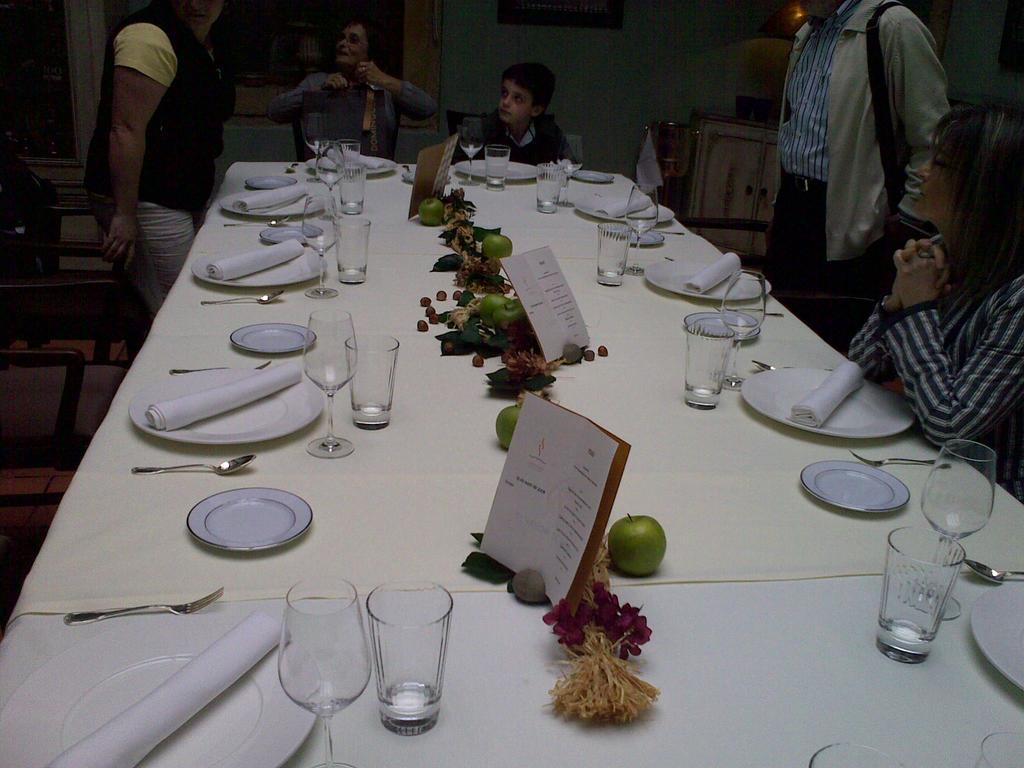What piece of furniture is present in the image? There is a table in the image. What utensils can be seen on the table? There are forks and spoons on the table. What else is on the table besides utensils? There are plates, glasses, and fruits on the table. Who is present in the image? There are people sitting on chairs in the image. What type of meat is being served in the downtown area in the image? There is no mention of meat or a downtown area in the image; it features a table with utensils, plates, glasses, fruits, and people sitting on chairs. 